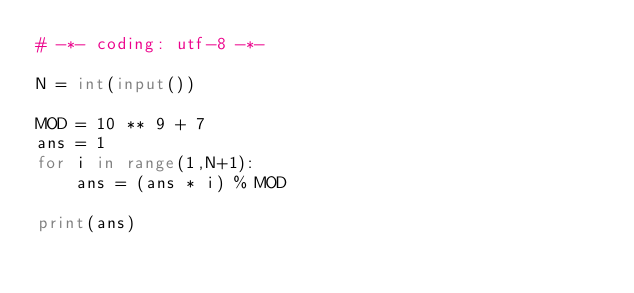<code> <loc_0><loc_0><loc_500><loc_500><_Python_># -*- coding: utf-8 -*-

N = int(input())

MOD = 10 ** 9 + 7
ans = 1
for i in range(1,N+1):
    ans = (ans * i) % MOD

print(ans)</code> 